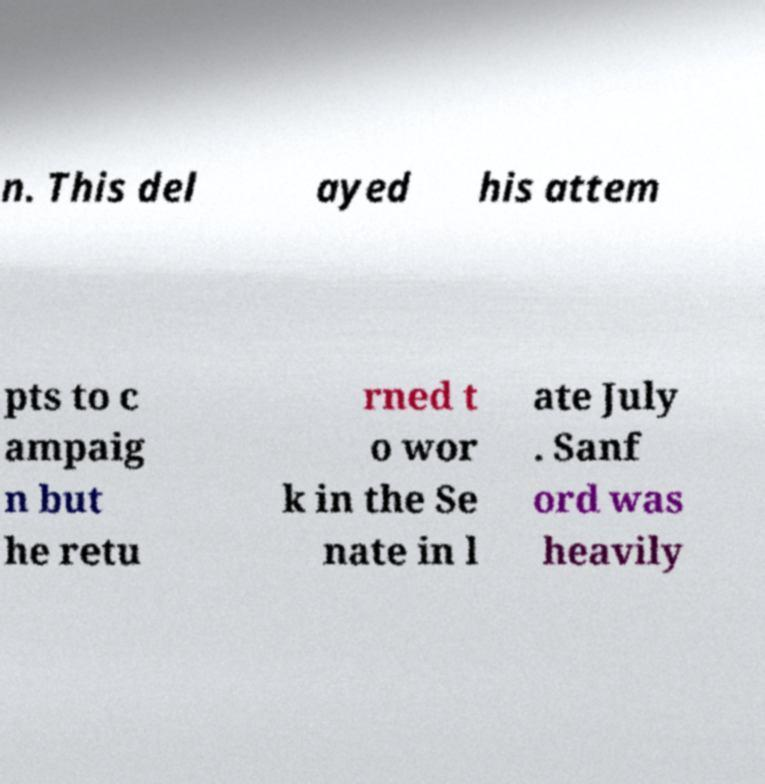Can you read and provide the text displayed in the image?This photo seems to have some interesting text. Can you extract and type it out for me? n. This del ayed his attem pts to c ampaig n but he retu rned t o wor k in the Se nate in l ate July . Sanf ord was heavily 